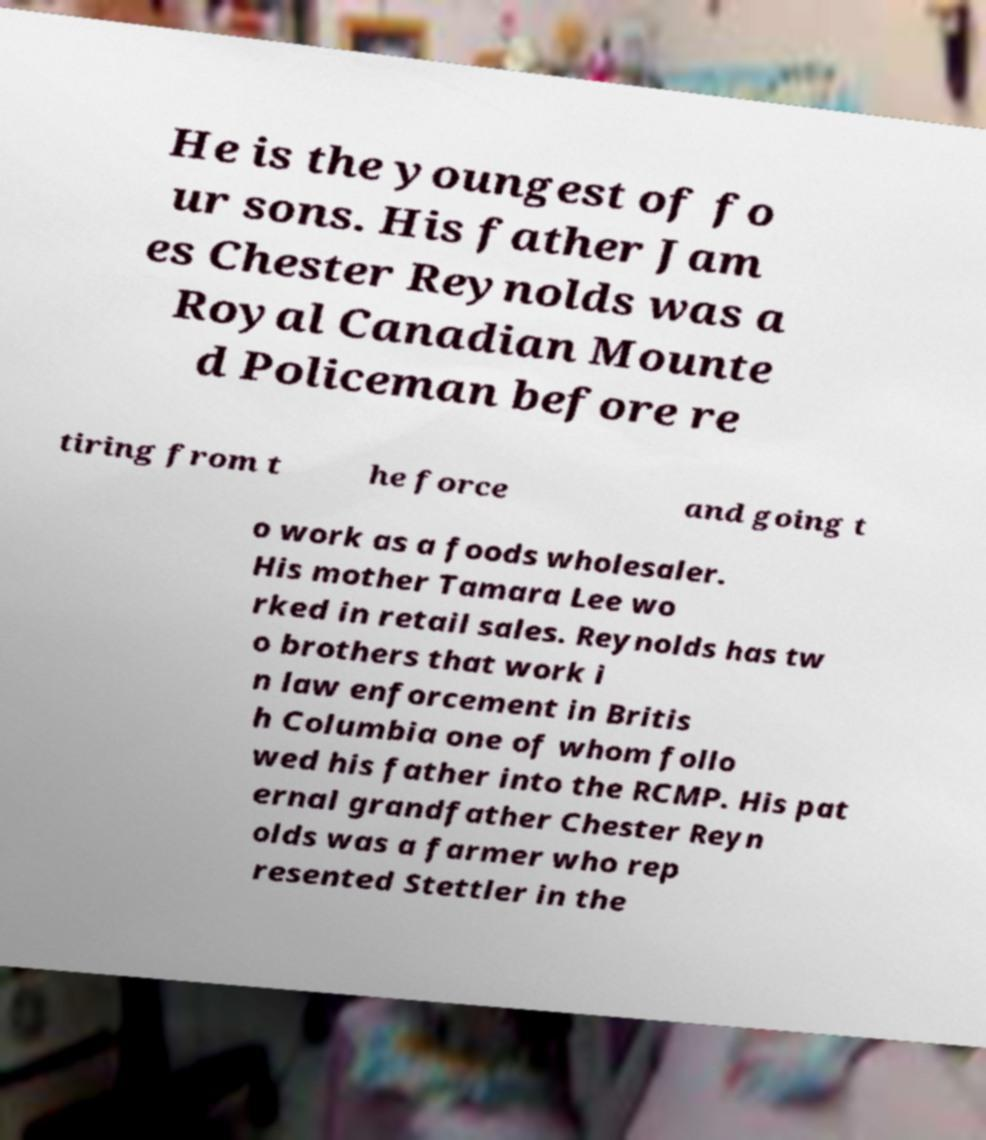For documentation purposes, I need the text within this image transcribed. Could you provide that? He is the youngest of fo ur sons. His father Jam es Chester Reynolds was a Royal Canadian Mounte d Policeman before re tiring from t he force and going t o work as a foods wholesaler. His mother Tamara Lee wo rked in retail sales. Reynolds has tw o brothers that work i n law enforcement in Britis h Columbia one of whom follo wed his father into the RCMP. His pat ernal grandfather Chester Reyn olds was a farmer who rep resented Stettler in the 